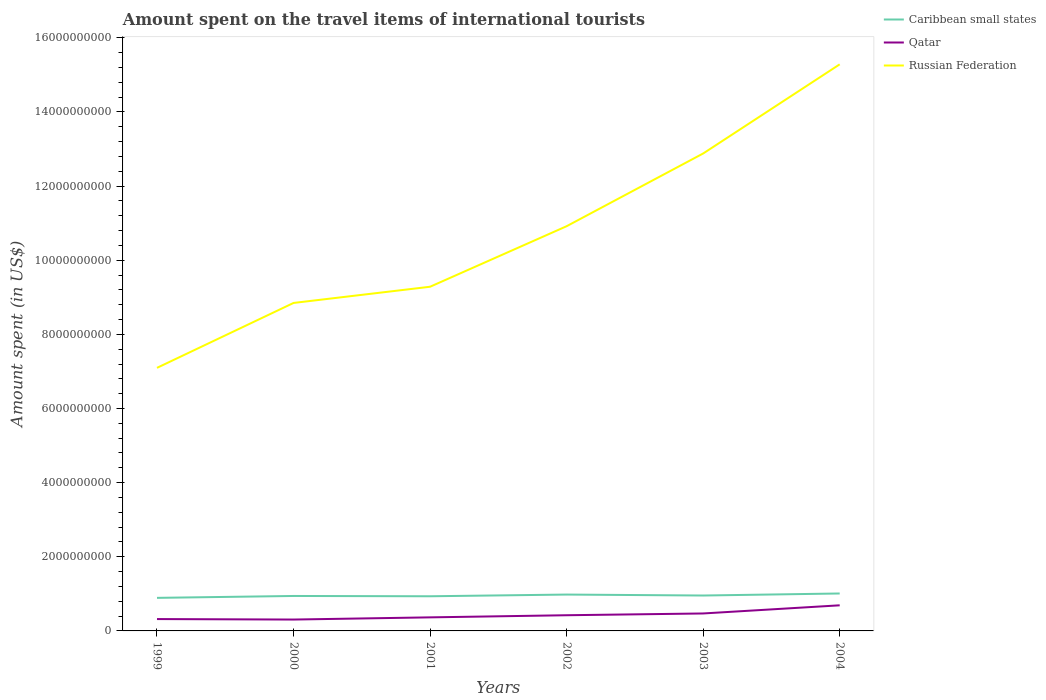How many different coloured lines are there?
Your answer should be very brief. 3. Does the line corresponding to Qatar intersect with the line corresponding to Russian Federation?
Provide a succinct answer. No. Is the number of lines equal to the number of legend labels?
Give a very brief answer. Yes. Across all years, what is the maximum amount spent on the travel items of international tourists in Russian Federation?
Offer a very short reply. 7.10e+09. In which year was the amount spent on the travel items of international tourists in Russian Federation maximum?
Ensure brevity in your answer.  1999. What is the total amount spent on the travel items of international tourists in Qatar in the graph?
Your answer should be compact. -2.20e+08. What is the difference between the highest and the second highest amount spent on the travel items of international tourists in Qatar?
Make the answer very short. 3.84e+08. What is the difference between the highest and the lowest amount spent on the travel items of international tourists in Russian Federation?
Your answer should be compact. 3. What is the difference between two consecutive major ticks on the Y-axis?
Give a very brief answer. 2.00e+09. Does the graph contain grids?
Your response must be concise. No. Where does the legend appear in the graph?
Your response must be concise. Top right. What is the title of the graph?
Give a very brief answer. Amount spent on the travel items of international tourists. Does "Samoa" appear as one of the legend labels in the graph?
Give a very brief answer. No. What is the label or title of the Y-axis?
Ensure brevity in your answer.  Amount spent (in US$). What is the Amount spent (in US$) of Caribbean small states in 1999?
Offer a very short reply. 8.92e+08. What is the Amount spent (in US$) of Qatar in 1999?
Your answer should be compact. 3.20e+08. What is the Amount spent (in US$) of Russian Federation in 1999?
Offer a very short reply. 7.10e+09. What is the Amount spent (in US$) of Caribbean small states in 2000?
Your response must be concise. 9.43e+08. What is the Amount spent (in US$) of Qatar in 2000?
Ensure brevity in your answer.  3.07e+08. What is the Amount spent (in US$) in Russian Federation in 2000?
Make the answer very short. 8.85e+09. What is the Amount spent (in US$) of Caribbean small states in 2001?
Offer a terse response. 9.35e+08. What is the Amount spent (in US$) in Qatar in 2001?
Ensure brevity in your answer.  3.66e+08. What is the Amount spent (in US$) of Russian Federation in 2001?
Keep it short and to the point. 9.28e+09. What is the Amount spent (in US$) of Caribbean small states in 2002?
Provide a succinct answer. 9.81e+08. What is the Amount spent (in US$) in Qatar in 2002?
Your response must be concise. 4.23e+08. What is the Amount spent (in US$) in Russian Federation in 2002?
Give a very brief answer. 1.09e+1. What is the Amount spent (in US$) of Caribbean small states in 2003?
Give a very brief answer. 9.55e+08. What is the Amount spent (in US$) in Qatar in 2003?
Provide a succinct answer. 4.71e+08. What is the Amount spent (in US$) in Russian Federation in 2003?
Provide a succinct answer. 1.29e+1. What is the Amount spent (in US$) of Caribbean small states in 2004?
Keep it short and to the point. 1.01e+09. What is the Amount spent (in US$) in Qatar in 2004?
Make the answer very short. 6.91e+08. What is the Amount spent (in US$) of Russian Federation in 2004?
Your response must be concise. 1.53e+1. Across all years, what is the maximum Amount spent (in US$) of Caribbean small states?
Offer a terse response. 1.01e+09. Across all years, what is the maximum Amount spent (in US$) in Qatar?
Give a very brief answer. 6.91e+08. Across all years, what is the maximum Amount spent (in US$) in Russian Federation?
Your answer should be compact. 1.53e+1. Across all years, what is the minimum Amount spent (in US$) in Caribbean small states?
Make the answer very short. 8.92e+08. Across all years, what is the minimum Amount spent (in US$) of Qatar?
Your answer should be very brief. 3.07e+08. Across all years, what is the minimum Amount spent (in US$) of Russian Federation?
Your answer should be very brief. 7.10e+09. What is the total Amount spent (in US$) in Caribbean small states in the graph?
Make the answer very short. 5.72e+09. What is the total Amount spent (in US$) in Qatar in the graph?
Provide a short and direct response. 2.58e+09. What is the total Amount spent (in US$) in Russian Federation in the graph?
Give a very brief answer. 6.43e+1. What is the difference between the Amount spent (in US$) in Caribbean small states in 1999 and that in 2000?
Your answer should be very brief. -5.10e+07. What is the difference between the Amount spent (in US$) in Qatar in 1999 and that in 2000?
Offer a very short reply. 1.30e+07. What is the difference between the Amount spent (in US$) in Russian Federation in 1999 and that in 2000?
Ensure brevity in your answer.  -1.75e+09. What is the difference between the Amount spent (in US$) of Caribbean small states in 1999 and that in 2001?
Keep it short and to the point. -4.30e+07. What is the difference between the Amount spent (in US$) in Qatar in 1999 and that in 2001?
Provide a short and direct response. -4.60e+07. What is the difference between the Amount spent (in US$) of Russian Federation in 1999 and that in 2001?
Your answer should be compact. -2.19e+09. What is the difference between the Amount spent (in US$) of Caribbean small states in 1999 and that in 2002?
Keep it short and to the point. -8.90e+07. What is the difference between the Amount spent (in US$) of Qatar in 1999 and that in 2002?
Your answer should be compact. -1.03e+08. What is the difference between the Amount spent (in US$) in Russian Federation in 1999 and that in 2002?
Make the answer very short. -3.82e+09. What is the difference between the Amount spent (in US$) of Caribbean small states in 1999 and that in 2003?
Offer a terse response. -6.30e+07. What is the difference between the Amount spent (in US$) of Qatar in 1999 and that in 2003?
Provide a succinct answer. -1.51e+08. What is the difference between the Amount spent (in US$) in Russian Federation in 1999 and that in 2003?
Make the answer very short. -5.78e+09. What is the difference between the Amount spent (in US$) in Caribbean small states in 1999 and that in 2004?
Offer a terse response. -1.18e+08. What is the difference between the Amount spent (in US$) of Qatar in 1999 and that in 2004?
Make the answer very short. -3.71e+08. What is the difference between the Amount spent (in US$) of Russian Federation in 1999 and that in 2004?
Keep it short and to the point. -8.19e+09. What is the difference between the Amount spent (in US$) of Qatar in 2000 and that in 2001?
Keep it short and to the point. -5.90e+07. What is the difference between the Amount spent (in US$) in Russian Federation in 2000 and that in 2001?
Ensure brevity in your answer.  -4.37e+08. What is the difference between the Amount spent (in US$) of Caribbean small states in 2000 and that in 2002?
Make the answer very short. -3.80e+07. What is the difference between the Amount spent (in US$) of Qatar in 2000 and that in 2002?
Provide a short and direct response. -1.16e+08. What is the difference between the Amount spent (in US$) of Russian Federation in 2000 and that in 2002?
Give a very brief answer. -2.07e+09. What is the difference between the Amount spent (in US$) of Caribbean small states in 2000 and that in 2003?
Make the answer very short. -1.20e+07. What is the difference between the Amount spent (in US$) in Qatar in 2000 and that in 2003?
Provide a succinct answer. -1.64e+08. What is the difference between the Amount spent (in US$) in Russian Federation in 2000 and that in 2003?
Ensure brevity in your answer.  -4.03e+09. What is the difference between the Amount spent (in US$) of Caribbean small states in 2000 and that in 2004?
Provide a succinct answer. -6.70e+07. What is the difference between the Amount spent (in US$) of Qatar in 2000 and that in 2004?
Your answer should be very brief. -3.84e+08. What is the difference between the Amount spent (in US$) in Russian Federation in 2000 and that in 2004?
Provide a short and direct response. -6.44e+09. What is the difference between the Amount spent (in US$) of Caribbean small states in 2001 and that in 2002?
Provide a succinct answer. -4.60e+07. What is the difference between the Amount spent (in US$) in Qatar in 2001 and that in 2002?
Your answer should be compact. -5.70e+07. What is the difference between the Amount spent (in US$) in Russian Federation in 2001 and that in 2002?
Keep it short and to the point. -1.63e+09. What is the difference between the Amount spent (in US$) of Caribbean small states in 2001 and that in 2003?
Your answer should be compact. -2.00e+07. What is the difference between the Amount spent (in US$) in Qatar in 2001 and that in 2003?
Your response must be concise. -1.05e+08. What is the difference between the Amount spent (in US$) in Russian Federation in 2001 and that in 2003?
Your answer should be compact. -3.60e+09. What is the difference between the Amount spent (in US$) of Caribbean small states in 2001 and that in 2004?
Provide a succinct answer. -7.50e+07. What is the difference between the Amount spent (in US$) in Qatar in 2001 and that in 2004?
Provide a short and direct response. -3.25e+08. What is the difference between the Amount spent (in US$) in Russian Federation in 2001 and that in 2004?
Offer a terse response. -6.00e+09. What is the difference between the Amount spent (in US$) in Caribbean small states in 2002 and that in 2003?
Make the answer very short. 2.60e+07. What is the difference between the Amount spent (in US$) in Qatar in 2002 and that in 2003?
Ensure brevity in your answer.  -4.80e+07. What is the difference between the Amount spent (in US$) of Russian Federation in 2002 and that in 2003?
Your answer should be very brief. -1.96e+09. What is the difference between the Amount spent (in US$) in Caribbean small states in 2002 and that in 2004?
Make the answer very short. -2.90e+07. What is the difference between the Amount spent (in US$) in Qatar in 2002 and that in 2004?
Your response must be concise. -2.68e+08. What is the difference between the Amount spent (in US$) in Russian Federation in 2002 and that in 2004?
Keep it short and to the point. -4.37e+09. What is the difference between the Amount spent (in US$) in Caribbean small states in 2003 and that in 2004?
Offer a very short reply. -5.50e+07. What is the difference between the Amount spent (in US$) in Qatar in 2003 and that in 2004?
Provide a succinct answer. -2.20e+08. What is the difference between the Amount spent (in US$) in Russian Federation in 2003 and that in 2004?
Offer a terse response. -2.40e+09. What is the difference between the Amount spent (in US$) of Caribbean small states in 1999 and the Amount spent (in US$) of Qatar in 2000?
Make the answer very short. 5.85e+08. What is the difference between the Amount spent (in US$) of Caribbean small states in 1999 and the Amount spent (in US$) of Russian Federation in 2000?
Your answer should be compact. -7.96e+09. What is the difference between the Amount spent (in US$) in Qatar in 1999 and the Amount spent (in US$) in Russian Federation in 2000?
Your response must be concise. -8.53e+09. What is the difference between the Amount spent (in US$) in Caribbean small states in 1999 and the Amount spent (in US$) in Qatar in 2001?
Your answer should be very brief. 5.26e+08. What is the difference between the Amount spent (in US$) in Caribbean small states in 1999 and the Amount spent (in US$) in Russian Federation in 2001?
Provide a succinct answer. -8.39e+09. What is the difference between the Amount spent (in US$) of Qatar in 1999 and the Amount spent (in US$) of Russian Federation in 2001?
Give a very brief answer. -8.96e+09. What is the difference between the Amount spent (in US$) in Caribbean small states in 1999 and the Amount spent (in US$) in Qatar in 2002?
Provide a succinct answer. 4.69e+08. What is the difference between the Amount spent (in US$) in Caribbean small states in 1999 and the Amount spent (in US$) in Russian Federation in 2002?
Provide a succinct answer. -1.00e+1. What is the difference between the Amount spent (in US$) of Qatar in 1999 and the Amount spent (in US$) of Russian Federation in 2002?
Your response must be concise. -1.06e+1. What is the difference between the Amount spent (in US$) of Caribbean small states in 1999 and the Amount spent (in US$) of Qatar in 2003?
Make the answer very short. 4.21e+08. What is the difference between the Amount spent (in US$) in Caribbean small states in 1999 and the Amount spent (in US$) in Russian Federation in 2003?
Your answer should be very brief. -1.20e+1. What is the difference between the Amount spent (in US$) in Qatar in 1999 and the Amount spent (in US$) in Russian Federation in 2003?
Ensure brevity in your answer.  -1.26e+1. What is the difference between the Amount spent (in US$) of Caribbean small states in 1999 and the Amount spent (in US$) of Qatar in 2004?
Provide a succinct answer. 2.01e+08. What is the difference between the Amount spent (in US$) in Caribbean small states in 1999 and the Amount spent (in US$) in Russian Federation in 2004?
Your answer should be very brief. -1.44e+1. What is the difference between the Amount spent (in US$) of Qatar in 1999 and the Amount spent (in US$) of Russian Federation in 2004?
Your answer should be very brief. -1.50e+1. What is the difference between the Amount spent (in US$) of Caribbean small states in 2000 and the Amount spent (in US$) of Qatar in 2001?
Your answer should be very brief. 5.77e+08. What is the difference between the Amount spent (in US$) in Caribbean small states in 2000 and the Amount spent (in US$) in Russian Federation in 2001?
Offer a very short reply. -8.34e+09. What is the difference between the Amount spent (in US$) in Qatar in 2000 and the Amount spent (in US$) in Russian Federation in 2001?
Offer a terse response. -8.98e+09. What is the difference between the Amount spent (in US$) of Caribbean small states in 2000 and the Amount spent (in US$) of Qatar in 2002?
Offer a terse response. 5.20e+08. What is the difference between the Amount spent (in US$) in Caribbean small states in 2000 and the Amount spent (in US$) in Russian Federation in 2002?
Your response must be concise. -9.98e+09. What is the difference between the Amount spent (in US$) in Qatar in 2000 and the Amount spent (in US$) in Russian Federation in 2002?
Offer a very short reply. -1.06e+1. What is the difference between the Amount spent (in US$) of Caribbean small states in 2000 and the Amount spent (in US$) of Qatar in 2003?
Make the answer very short. 4.72e+08. What is the difference between the Amount spent (in US$) in Caribbean small states in 2000 and the Amount spent (in US$) in Russian Federation in 2003?
Give a very brief answer. -1.19e+1. What is the difference between the Amount spent (in US$) of Qatar in 2000 and the Amount spent (in US$) of Russian Federation in 2003?
Give a very brief answer. -1.26e+1. What is the difference between the Amount spent (in US$) of Caribbean small states in 2000 and the Amount spent (in US$) of Qatar in 2004?
Your response must be concise. 2.52e+08. What is the difference between the Amount spent (in US$) in Caribbean small states in 2000 and the Amount spent (in US$) in Russian Federation in 2004?
Provide a succinct answer. -1.43e+1. What is the difference between the Amount spent (in US$) of Qatar in 2000 and the Amount spent (in US$) of Russian Federation in 2004?
Ensure brevity in your answer.  -1.50e+1. What is the difference between the Amount spent (in US$) of Caribbean small states in 2001 and the Amount spent (in US$) of Qatar in 2002?
Provide a succinct answer. 5.12e+08. What is the difference between the Amount spent (in US$) of Caribbean small states in 2001 and the Amount spent (in US$) of Russian Federation in 2002?
Provide a short and direct response. -9.98e+09. What is the difference between the Amount spent (in US$) of Qatar in 2001 and the Amount spent (in US$) of Russian Federation in 2002?
Make the answer very short. -1.06e+1. What is the difference between the Amount spent (in US$) in Caribbean small states in 2001 and the Amount spent (in US$) in Qatar in 2003?
Your answer should be compact. 4.64e+08. What is the difference between the Amount spent (in US$) of Caribbean small states in 2001 and the Amount spent (in US$) of Russian Federation in 2003?
Ensure brevity in your answer.  -1.19e+1. What is the difference between the Amount spent (in US$) in Qatar in 2001 and the Amount spent (in US$) in Russian Federation in 2003?
Give a very brief answer. -1.25e+1. What is the difference between the Amount spent (in US$) in Caribbean small states in 2001 and the Amount spent (in US$) in Qatar in 2004?
Your answer should be very brief. 2.44e+08. What is the difference between the Amount spent (in US$) in Caribbean small states in 2001 and the Amount spent (in US$) in Russian Federation in 2004?
Your answer should be very brief. -1.44e+1. What is the difference between the Amount spent (in US$) in Qatar in 2001 and the Amount spent (in US$) in Russian Federation in 2004?
Provide a short and direct response. -1.49e+1. What is the difference between the Amount spent (in US$) of Caribbean small states in 2002 and the Amount spent (in US$) of Qatar in 2003?
Make the answer very short. 5.10e+08. What is the difference between the Amount spent (in US$) in Caribbean small states in 2002 and the Amount spent (in US$) in Russian Federation in 2003?
Offer a terse response. -1.19e+1. What is the difference between the Amount spent (in US$) in Qatar in 2002 and the Amount spent (in US$) in Russian Federation in 2003?
Provide a succinct answer. -1.25e+1. What is the difference between the Amount spent (in US$) in Caribbean small states in 2002 and the Amount spent (in US$) in Qatar in 2004?
Your answer should be very brief. 2.90e+08. What is the difference between the Amount spent (in US$) of Caribbean small states in 2002 and the Amount spent (in US$) of Russian Federation in 2004?
Give a very brief answer. -1.43e+1. What is the difference between the Amount spent (in US$) in Qatar in 2002 and the Amount spent (in US$) in Russian Federation in 2004?
Your answer should be compact. -1.49e+1. What is the difference between the Amount spent (in US$) in Caribbean small states in 2003 and the Amount spent (in US$) in Qatar in 2004?
Provide a succinct answer. 2.64e+08. What is the difference between the Amount spent (in US$) in Caribbean small states in 2003 and the Amount spent (in US$) in Russian Federation in 2004?
Provide a succinct answer. -1.43e+1. What is the difference between the Amount spent (in US$) of Qatar in 2003 and the Amount spent (in US$) of Russian Federation in 2004?
Your answer should be very brief. -1.48e+1. What is the average Amount spent (in US$) of Caribbean small states per year?
Offer a terse response. 9.53e+08. What is the average Amount spent (in US$) of Qatar per year?
Your answer should be compact. 4.30e+08. What is the average Amount spent (in US$) in Russian Federation per year?
Offer a terse response. 1.07e+1. In the year 1999, what is the difference between the Amount spent (in US$) of Caribbean small states and Amount spent (in US$) of Qatar?
Your response must be concise. 5.72e+08. In the year 1999, what is the difference between the Amount spent (in US$) in Caribbean small states and Amount spent (in US$) in Russian Federation?
Provide a short and direct response. -6.20e+09. In the year 1999, what is the difference between the Amount spent (in US$) in Qatar and Amount spent (in US$) in Russian Federation?
Your answer should be very brief. -6.78e+09. In the year 2000, what is the difference between the Amount spent (in US$) in Caribbean small states and Amount spent (in US$) in Qatar?
Offer a terse response. 6.36e+08. In the year 2000, what is the difference between the Amount spent (in US$) of Caribbean small states and Amount spent (in US$) of Russian Federation?
Keep it short and to the point. -7.90e+09. In the year 2000, what is the difference between the Amount spent (in US$) in Qatar and Amount spent (in US$) in Russian Federation?
Your answer should be compact. -8.54e+09. In the year 2001, what is the difference between the Amount spent (in US$) in Caribbean small states and Amount spent (in US$) in Qatar?
Make the answer very short. 5.69e+08. In the year 2001, what is the difference between the Amount spent (in US$) in Caribbean small states and Amount spent (in US$) in Russian Federation?
Provide a short and direct response. -8.35e+09. In the year 2001, what is the difference between the Amount spent (in US$) in Qatar and Amount spent (in US$) in Russian Federation?
Offer a very short reply. -8.92e+09. In the year 2002, what is the difference between the Amount spent (in US$) in Caribbean small states and Amount spent (in US$) in Qatar?
Give a very brief answer. 5.58e+08. In the year 2002, what is the difference between the Amount spent (in US$) of Caribbean small states and Amount spent (in US$) of Russian Federation?
Provide a succinct answer. -9.94e+09. In the year 2002, what is the difference between the Amount spent (in US$) of Qatar and Amount spent (in US$) of Russian Federation?
Provide a short and direct response. -1.05e+1. In the year 2003, what is the difference between the Amount spent (in US$) in Caribbean small states and Amount spent (in US$) in Qatar?
Make the answer very short. 4.84e+08. In the year 2003, what is the difference between the Amount spent (in US$) of Caribbean small states and Amount spent (in US$) of Russian Federation?
Make the answer very short. -1.19e+1. In the year 2003, what is the difference between the Amount spent (in US$) of Qatar and Amount spent (in US$) of Russian Federation?
Ensure brevity in your answer.  -1.24e+1. In the year 2004, what is the difference between the Amount spent (in US$) in Caribbean small states and Amount spent (in US$) in Qatar?
Provide a succinct answer. 3.19e+08. In the year 2004, what is the difference between the Amount spent (in US$) in Caribbean small states and Amount spent (in US$) in Russian Federation?
Provide a succinct answer. -1.43e+1. In the year 2004, what is the difference between the Amount spent (in US$) in Qatar and Amount spent (in US$) in Russian Federation?
Offer a very short reply. -1.46e+1. What is the ratio of the Amount spent (in US$) of Caribbean small states in 1999 to that in 2000?
Your response must be concise. 0.95. What is the ratio of the Amount spent (in US$) of Qatar in 1999 to that in 2000?
Your response must be concise. 1.04. What is the ratio of the Amount spent (in US$) of Russian Federation in 1999 to that in 2000?
Provide a short and direct response. 0.8. What is the ratio of the Amount spent (in US$) in Caribbean small states in 1999 to that in 2001?
Make the answer very short. 0.95. What is the ratio of the Amount spent (in US$) of Qatar in 1999 to that in 2001?
Give a very brief answer. 0.87. What is the ratio of the Amount spent (in US$) in Russian Federation in 1999 to that in 2001?
Make the answer very short. 0.76. What is the ratio of the Amount spent (in US$) in Caribbean small states in 1999 to that in 2002?
Make the answer very short. 0.91. What is the ratio of the Amount spent (in US$) in Qatar in 1999 to that in 2002?
Offer a very short reply. 0.76. What is the ratio of the Amount spent (in US$) in Russian Federation in 1999 to that in 2002?
Your response must be concise. 0.65. What is the ratio of the Amount spent (in US$) of Caribbean small states in 1999 to that in 2003?
Keep it short and to the point. 0.93. What is the ratio of the Amount spent (in US$) of Qatar in 1999 to that in 2003?
Give a very brief answer. 0.68. What is the ratio of the Amount spent (in US$) of Russian Federation in 1999 to that in 2003?
Give a very brief answer. 0.55. What is the ratio of the Amount spent (in US$) of Caribbean small states in 1999 to that in 2004?
Ensure brevity in your answer.  0.88. What is the ratio of the Amount spent (in US$) in Qatar in 1999 to that in 2004?
Your answer should be compact. 0.46. What is the ratio of the Amount spent (in US$) in Russian Federation in 1999 to that in 2004?
Ensure brevity in your answer.  0.46. What is the ratio of the Amount spent (in US$) of Caribbean small states in 2000 to that in 2001?
Offer a very short reply. 1.01. What is the ratio of the Amount spent (in US$) of Qatar in 2000 to that in 2001?
Make the answer very short. 0.84. What is the ratio of the Amount spent (in US$) of Russian Federation in 2000 to that in 2001?
Your answer should be very brief. 0.95. What is the ratio of the Amount spent (in US$) of Caribbean small states in 2000 to that in 2002?
Provide a succinct answer. 0.96. What is the ratio of the Amount spent (in US$) in Qatar in 2000 to that in 2002?
Offer a terse response. 0.73. What is the ratio of the Amount spent (in US$) in Russian Federation in 2000 to that in 2002?
Your response must be concise. 0.81. What is the ratio of the Amount spent (in US$) of Caribbean small states in 2000 to that in 2003?
Provide a succinct answer. 0.99. What is the ratio of the Amount spent (in US$) of Qatar in 2000 to that in 2003?
Ensure brevity in your answer.  0.65. What is the ratio of the Amount spent (in US$) of Russian Federation in 2000 to that in 2003?
Give a very brief answer. 0.69. What is the ratio of the Amount spent (in US$) of Caribbean small states in 2000 to that in 2004?
Keep it short and to the point. 0.93. What is the ratio of the Amount spent (in US$) of Qatar in 2000 to that in 2004?
Your answer should be very brief. 0.44. What is the ratio of the Amount spent (in US$) in Russian Federation in 2000 to that in 2004?
Your answer should be compact. 0.58. What is the ratio of the Amount spent (in US$) in Caribbean small states in 2001 to that in 2002?
Keep it short and to the point. 0.95. What is the ratio of the Amount spent (in US$) of Qatar in 2001 to that in 2002?
Provide a succinct answer. 0.87. What is the ratio of the Amount spent (in US$) of Russian Federation in 2001 to that in 2002?
Provide a succinct answer. 0.85. What is the ratio of the Amount spent (in US$) in Caribbean small states in 2001 to that in 2003?
Make the answer very short. 0.98. What is the ratio of the Amount spent (in US$) of Qatar in 2001 to that in 2003?
Offer a terse response. 0.78. What is the ratio of the Amount spent (in US$) of Russian Federation in 2001 to that in 2003?
Provide a short and direct response. 0.72. What is the ratio of the Amount spent (in US$) in Caribbean small states in 2001 to that in 2004?
Make the answer very short. 0.93. What is the ratio of the Amount spent (in US$) in Qatar in 2001 to that in 2004?
Give a very brief answer. 0.53. What is the ratio of the Amount spent (in US$) in Russian Federation in 2001 to that in 2004?
Keep it short and to the point. 0.61. What is the ratio of the Amount spent (in US$) in Caribbean small states in 2002 to that in 2003?
Your response must be concise. 1.03. What is the ratio of the Amount spent (in US$) in Qatar in 2002 to that in 2003?
Your answer should be very brief. 0.9. What is the ratio of the Amount spent (in US$) of Russian Federation in 2002 to that in 2003?
Offer a very short reply. 0.85. What is the ratio of the Amount spent (in US$) in Caribbean small states in 2002 to that in 2004?
Provide a short and direct response. 0.97. What is the ratio of the Amount spent (in US$) of Qatar in 2002 to that in 2004?
Your answer should be compact. 0.61. What is the ratio of the Amount spent (in US$) in Caribbean small states in 2003 to that in 2004?
Your response must be concise. 0.95. What is the ratio of the Amount spent (in US$) of Qatar in 2003 to that in 2004?
Provide a succinct answer. 0.68. What is the ratio of the Amount spent (in US$) in Russian Federation in 2003 to that in 2004?
Provide a short and direct response. 0.84. What is the difference between the highest and the second highest Amount spent (in US$) of Caribbean small states?
Provide a short and direct response. 2.90e+07. What is the difference between the highest and the second highest Amount spent (in US$) in Qatar?
Make the answer very short. 2.20e+08. What is the difference between the highest and the second highest Amount spent (in US$) of Russian Federation?
Offer a terse response. 2.40e+09. What is the difference between the highest and the lowest Amount spent (in US$) in Caribbean small states?
Ensure brevity in your answer.  1.18e+08. What is the difference between the highest and the lowest Amount spent (in US$) of Qatar?
Give a very brief answer. 3.84e+08. What is the difference between the highest and the lowest Amount spent (in US$) of Russian Federation?
Make the answer very short. 8.19e+09. 